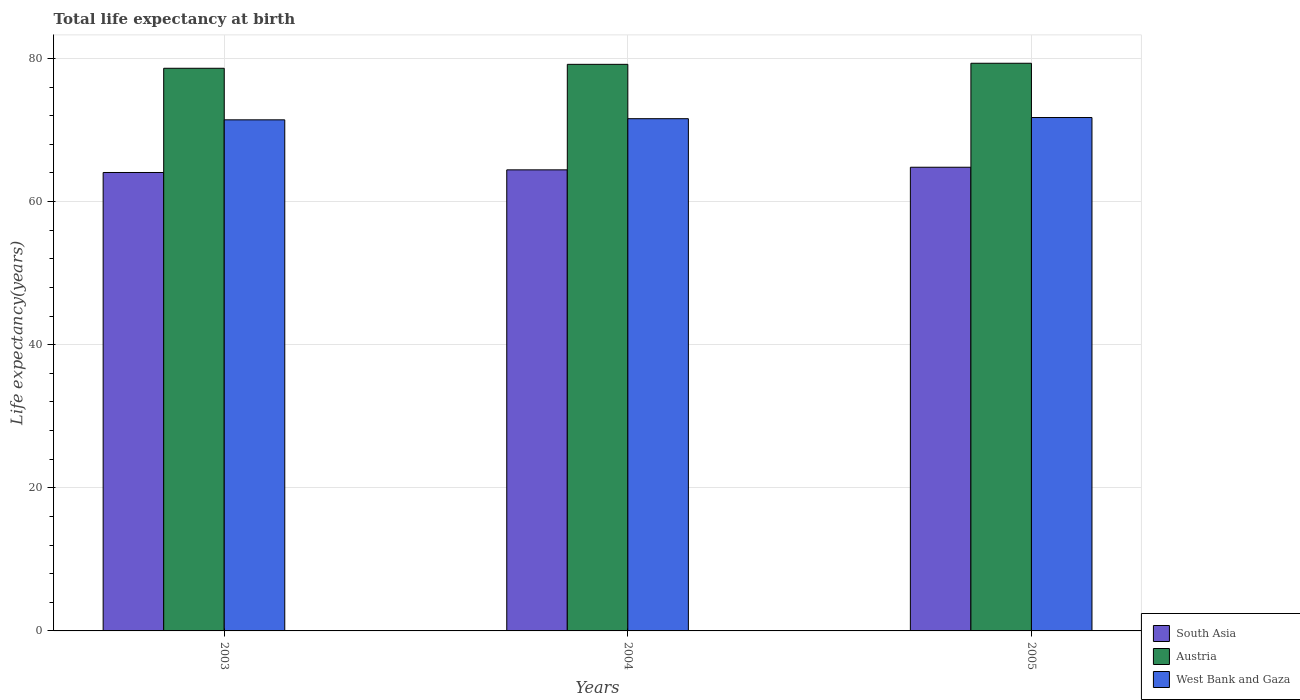How many groups of bars are there?
Provide a short and direct response. 3. Are the number of bars per tick equal to the number of legend labels?
Provide a succinct answer. Yes. How many bars are there on the 1st tick from the left?
Your response must be concise. 3. What is the label of the 3rd group of bars from the left?
Your answer should be compact. 2005. What is the life expectancy at birth in in West Bank and Gaza in 2004?
Provide a succinct answer. 71.59. Across all years, what is the maximum life expectancy at birth in in West Bank and Gaza?
Your answer should be compact. 71.75. Across all years, what is the minimum life expectancy at birth in in South Asia?
Offer a terse response. 64.07. In which year was the life expectancy at birth in in South Asia maximum?
Provide a succinct answer. 2005. In which year was the life expectancy at birth in in West Bank and Gaza minimum?
Ensure brevity in your answer.  2003. What is the total life expectancy at birth in in West Bank and Gaza in the graph?
Make the answer very short. 214.76. What is the difference between the life expectancy at birth in in Austria in 2003 and that in 2004?
Your answer should be compact. -0.55. What is the difference between the life expectancy at birth in in South Asia in 2003 and the life expectancy at birth in in Austria in 2004?
Your answer should be very brief. -15.11. What is the average life expectancy at birth in in Austria per year?
Provide a short and direct response. 79.05. In the year 2005, what is the difference between the life expectancy at birth in in South Asia and life expectancy at birth in in West Bank and Gaza?
Your answer should be very brief. -6.95. In how many years, is the life expectancy at birth in in South Asia greater than 56 years?
Your answer should be compact. 3. What is the ratio of the life expectancy at birth in in Austria in 2004 to that in 2005?
Offer a very short reply. 1. Is the life expectancy at birth in in Austria in 2003 less than that in 2004?
Give a very brief answer. Yes. Is the difference between the life expectancy at birth in in South Asia in 2003 and 2004 greater than the difference between the life expectancy at birth in in West Bank and Gaza in 2003 and 2004?
Ensure brevity in your answer.  No. What is the difference between the highest and the second highest life expectancy at birth in in Austria?
Provide a succinct answer. 0.15. What is the difference between the highest and the lowest life expectancy at birth in in South Asia?
Make the answer very short. 0.73. In how many years, is the life expectancy at birth in in West Bank and Gaza greater than the average life expectancy at birth in in West Bank and Gaza taken over all years?
Make the answer very short. 1. Is the sum of the life expectancy at birth in in Austria in 2004 and 2005 greater than the maximum life expectancy at birth in in South Asia across all years?
Your answer should be compact. Yes. What does the 2nd bar from the left in 2003 represents?
Provide a succinct answer. Austria. What does the 1st bar from the right in 2003 represents?
Your answer should be very brief. West Bank and Gaza. Is it the case that in every year, the sum of the life expectancy at birth in in South Asia and life expectancy at birth in in West Bank and Gaza is greater than the life expectancy at birth in in Austria?
Ensure brevity in your answer.  Yes. How many bars are there?
Make the answer very short. 9. How many years are there in the graph?
Keep it short and to the point. 3. What is the difference between two consecutive major ticks on the Y-axis?
Your answer should be very brief. 20. Where does the legend appear in the graph?
Provide a short and direct response. Bottom right. How are the legend labels stacked?
Give a very brief answer. Vertical. What is the title of the graph?
Keep it short and to the point. Total life expectancy at birth. Does "Japan" appear as one of the legend labels in the graph?
Keep it short and to the point. No. What is the label or title of the Y-axis?
Offer a terse response. Life expectancy(years). What is the Life expectancy(years) of South Asia in 2003?
Make the answer very short. 64.07. What is the Life expectancy(years) in Austria in 2003?
Give a very brief answer. 78.63. What is the Life expectancy(years) of West Bank and Gaza in 2003?
Keep it short and to the point. 71.42. What is the Life expectancy(years) of South Asia in 2004?
Provide a succinct answer. 64.43. What is the Life expectancy(years) in Austria in 2004?
Keep it short and to the point. 79.18. What is the Life expectancy(years) in West Bank and Gaza in 2004?
Your answer should be compact. 71.59. What is the Life expectancy(years) of South Asia in 2005?
Make the answer very short. 64.8. What is the Life expectancy(years) in Austria in 2005?
Provide a succinct answer. 79.33. What is the Life expectancy(years) in West Bank and Gaza in 2005?
Give a very brief answer. 71.75. Across all years, what is the maximum Life expectancy(years) of South Asia?
Provide a succinct answer. 64.8. Across all years, what is the maximum Life expectancy(years) in Austria?
Your answer should be very brief. 79.33. Across all years, what is the maximum Life expectancy(years) in West Bank and Gaza?
Your response must be concise. 71.75. Across all years, what is the minimum Life expectancy(years) in South Asia?
Keep it short and to the point. 64.07. Across all years, what is the minimum Life expectancy(years) in Austria?
Your answer should be compact. 78.63. Across all years, what is the minimum Life expectancy(years) in West Bank and Gaza?
Your answer should be compact. 71.42. What is the total Life expectancy(years) of South Asia in the graph?
Ensure brevity in your answer.  193.3. What is the total Life expectancy(years) of Austria in the graph?
Offer a very short reply. 237.14. What is the total Life expectancy(years) in West Bank and Gaza in the graph?
Your answer should be very brief. 214.76. What is the difference between the Life expectancy(years) in South Asia in 2003 and that in 2004?
Offer a very short reply. -0.37. What is the difference between the Life expectancy(years) of Austria in 2003 and that in 2004?
Your answer should be compact. -0.55. What is the difference between the Life expectancy(years) in West Bank and Gaza in 2003 and that in 2004?
Provide a short and direct response. -0.16. What is the difference between the Life expectancy(years) in South Asia in 2003 and that in 2005?
Ensure brevity in your answer.  -0.73. What is the difference between the Life expectancy(years) of West Bank and Gaza in 2003 and that in 2005?
Provide a succinct answer. -0.32. What is the difference between the Life expectancy(years) in South Asia in 2004 and that in 2005?
Offer a very short reply. -0.37. What is the difference between the Life expectancy(years) of Austria in 2004 and that in 2005?
Your answer should be compact. -0.15. What is the difference between the Life expectancy(years) of West Bank and Gaza in 2004 and that in 2005?
Ensure brevity in your answer.  -0.16. What is the difference between the Life expectancy(years) in South Asia in 2003 and the Life expectancy(years) in Austria in 2004?
Offer a terse response. -15.11. What is the difference between the Life expectancy(years) in South Asia in 2003 and the Life expectancy(years) in West Bank and Gaza in 2004?
Offer a very short reply. -7.52. What is the difference between the Life expectancy(years) in Austria in 2003 and the Life expectancy(years) in West Bank and Gaza in 2004?
Offer a very short reply. 7.05. What is the difference between the Life expectancy(years) of South Asia in 2003 and the Life expectancy(years) of Austria in 2005?
Your response must be concise. -15.27. What is the difference between the Life expectancy(years) of South Asia in 2003 and the Life expectancy(years) of West Bank and Gaza in 2005?
Your answer should be compact. -7.68. What is the difference between the Life expectancy(years) in Austria in 2003 and the Life expectancy(years) in West Bank and Gaza in 2005?
Provide a short and direct response. 6.88. What is the difference between the Life expectancy(years) of South Asia in 2004 and the Life expectancy(years) of Austria in 2005?
Provide a succinct answer. -14.9. What is the difference between the Life expectancy(years) in South Asia in 2004 and the Life expectancy(years) in West Bank and Gaza in 2005?
Provide a succinct answer. -7.31. What is the difference between the Life expectancy(years) in Austria in 2004 and the Life expectancy(years) in West Bank and Gaza in 2005?
Ensure brevity in your answer.  7.43. What is the average Life expectancy(years) of South Asia per year?
Provide a short and direct response. 64.43. What is the average Life expectancy(years) of Austria per year?
Provide a short and direct response. 79.05. What is the average Life expectancy(years) of West Bank and Gaza per year?
Offer a terse response. 71.59. In the year 2003, what is the difference between the Life expectancy(years) in South Asia and Life expectancy(years) in Austria?
Offer a very short reply. -14.57. In the year 2003, what is the difference between the Life expectancy(years) in South Asia and Life expectancy(years) in West Bank and Gaza?
Keep it short and to the point. -7.36. In the year 2003, what is the difference between the Life expectancy(years) in Austria and Life expectancy(years) in West Bank and Gaza?
Provide a succinct answer. 7.21. In the year 2004, what is the difference between the Life expectancy(years) of South Asia and Life expectancy(years) of Austria?
Make the answer very short. -14.75. In the year 2004, what is the difference between the Life expectancy(years) in South Asia and Life expectancy(years) in West Bank and Gaza?
Offer a very short reply. -7.15. In the year 2004, what is the difference between the Life expectancy(years) of Austria and Life expectancy(years) of West Bank and Gaza?
Ensure brevity in your answer.  7.6. In the year 2005, what is the difference between the Life expectancy(years) of South Asia and Life expectancy(years) of Austria?
Offer a terse response. -14.53. In the year 2005, what is the difference between the Life expectancy(years) in South Asia and Life expectancy(years) in West Bank and Gaza?
Provide a short and direct response. -6.95. In the year 2005, what is the difference between the Life expectancy(years) in Austria and Life expectancy(years) in West Bank and Gaza?
Give a very brief answer. 7.58. What is the ratio of the Life expectancy(years) in West Bank and Gaza in 2003 to that in 2004?
Keep it short and to the point. 1. What is the ratio of the Life expectancy(years) of South Asia in 2003 to that in 2005?
Your response must be concise. 0.99. What is the ratio of the Life expectancy(years) in Austria in 2003 to that in 2005?
Make the answer very short. 0.99. What is the ratio of the Life expectancy(years) of South Asia in 2004 to that in 2005?
Your answer should be compact. 0.99. What is the ratio of the Life expectancy(years) of Austria in 2004 to that in 2005?
Your answer should be compact. 1. What is the ratio of the Life expectancy(years) of West Bank and Gaza in 2004 to that in 2005?
Offer a terse response. 1. What is the difference between the highest and the second highest Life expectancy(years) in South Asia?
Your answer should be compact. 0.37. What is the difference between the highest and the second highest Life expectancy(years) in Austria?
Offer a very short reply. 0.15. What is the difference between the highest and the second highest Life expectancy(years) of West Bank and Gaza?
Offer a terse response. 0.16. What is the difference between the highest and the lowest Life expectancy(years) in South Asia?
Give a very brief answer. 0.73. What is the difference between the highest and the lowest Life expectancy(years) in Austria?
Your response must be concise. 0.7. What is the difference between the highest and the lowest Life expectancy(years) of West Bank and Gaza?
Ensure brevity in your answer.  0.32. 